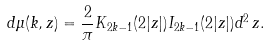<formula> <loc_0><loc_0><loc_500><loc_500>d \mu ( k , z ) = \frac { 2 } { \pi } K _ { 2 k - 1 } ( 2 | z | ) I _ { 2 k - 1 } ( 2 | z | ) d ^ { 2 } \, z .</formula> 